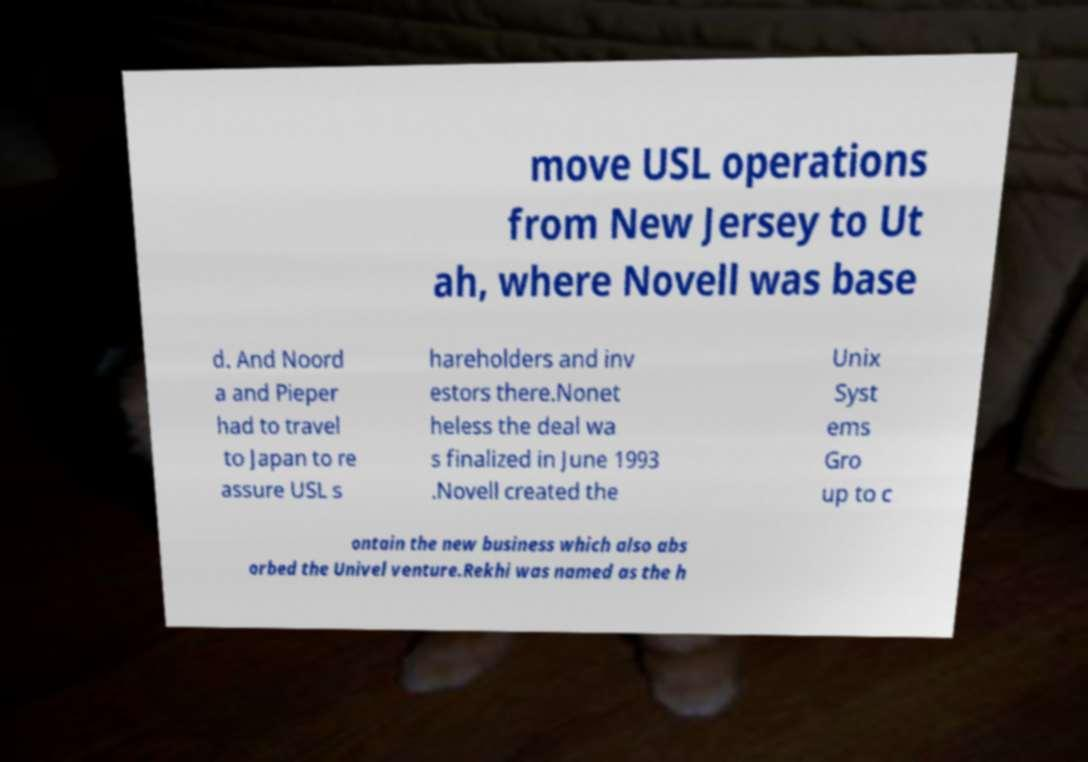What messages or text are displayed in this image? I need them in a readable, typed format. move USL operations from New Jersey to Ut ah, where Novell was base d. And Noord a and Pieper had to travel to Japan to re assure USL s hareholders and inv estors there.Nonet heless the deal wa s finalized in June 1993 .Novell created the Unix Syst ems Gro up to c ontain the new business which also abs orbed the Univel venture.Rekhi was named as the h 